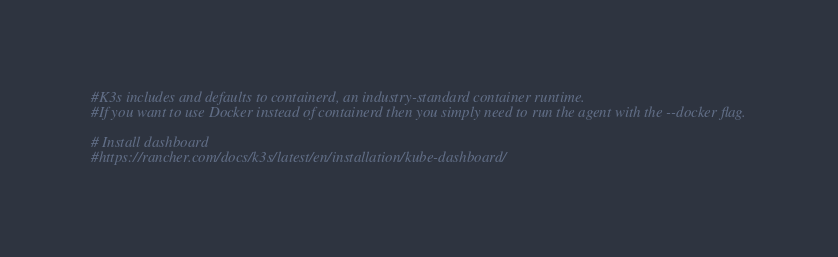<code> <loc_0><loc_0><loc_500><loc_500><_Bash_>#K3s includes and defaults to containerd, an industry-standard container runtime.
#If you want to use Docker instead of containerd then you simply need to run the agent with the --docker flag.

# Install dashboard
#https://rancher.com/docs/k3s/latest/en/installation/kube-dashboard/
</code> 